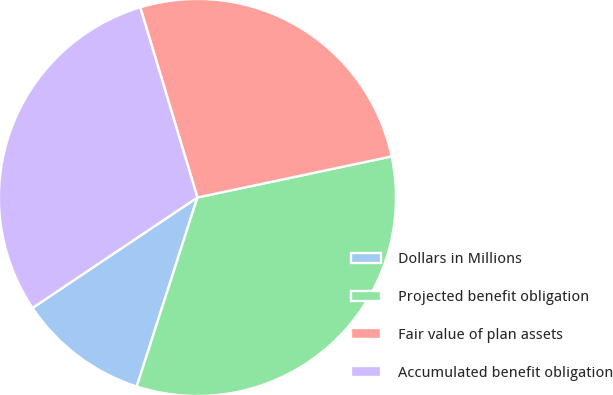Convert chart. <chart><loc_0><loc_0><loc_500><loc_500><pie_chart><fcel>Dollars in Millions<fcel>Projected benefit obligation<fcel>Fair value of plan assets<fcel>Accumulated benefit obligation<nl><fcel>10.66%<fcel>33.26%<fcel>26.33%<fcel>29.74%<nl></chart> 